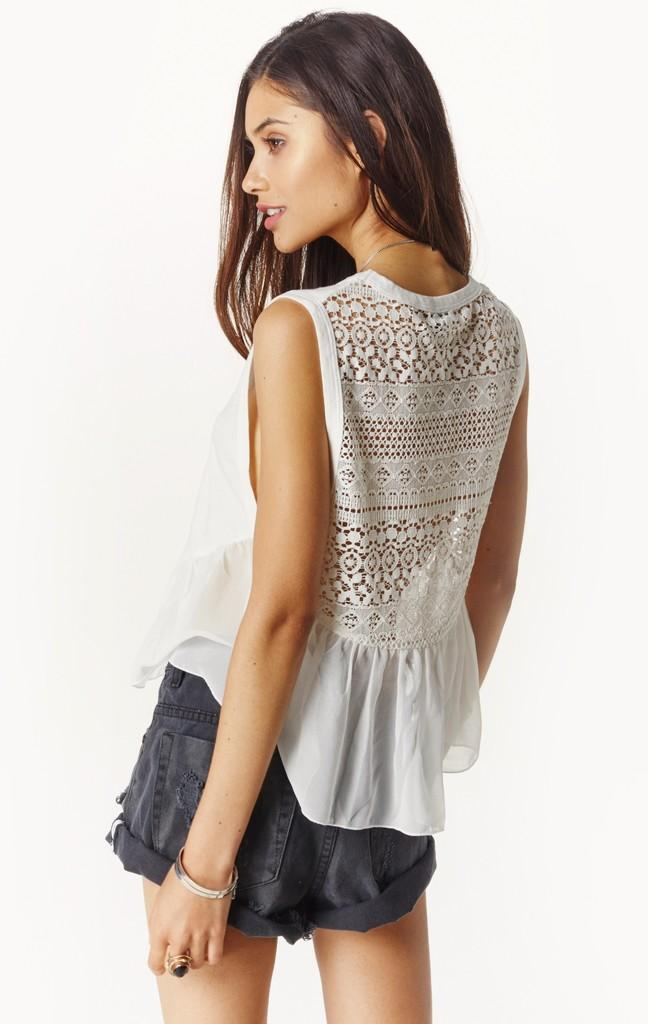What is the main subject of the image? There is a woman standing in the image. What can be seen in the background of the image? The background of the image is white. What type of ice can be seen melting on the woman's head in the image? There is no ice present in the image, and therefore no such activity can be observed. 